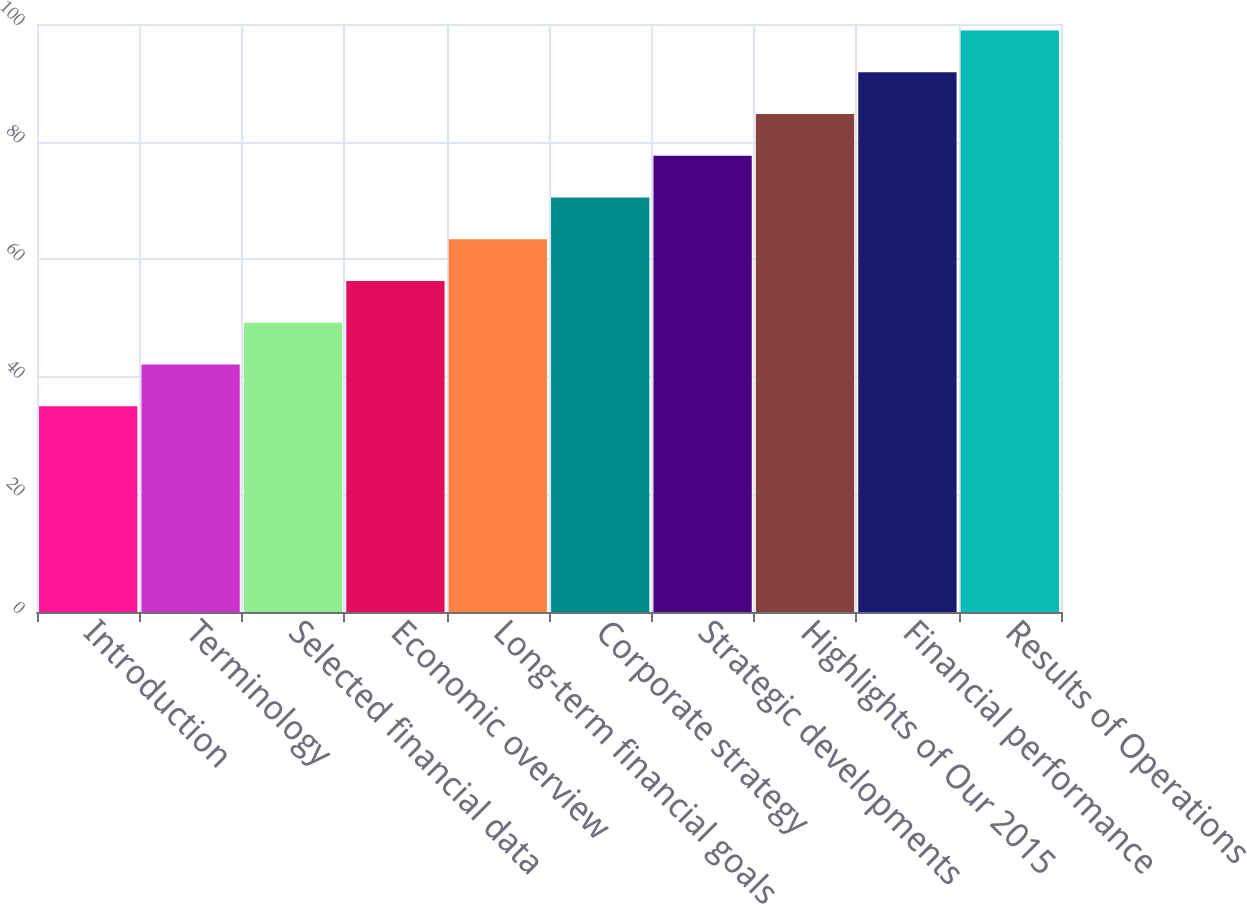Convert chart. <chart><loc_0><loc_0><loc_500><loc_500><bar_chart><fcel>Introduction<fcel>Terminology<fcel>Selected financial data<fcel>Economic overview<fcel>Long-term financial goals<fcel>Corporate strategy<fcel>Strategic developments<fcel>Highlights of Our 2015<fcel>Financial performance<fcel>Results of Operations<nl><fcel>35<fcel>42.1<fcel>49.2<fcel>56.3<fcel>63.4<fcel>70.5<fcel>77.6<fcel>84.7<fcel>91.8<fcel>98.9<nl></chart> 